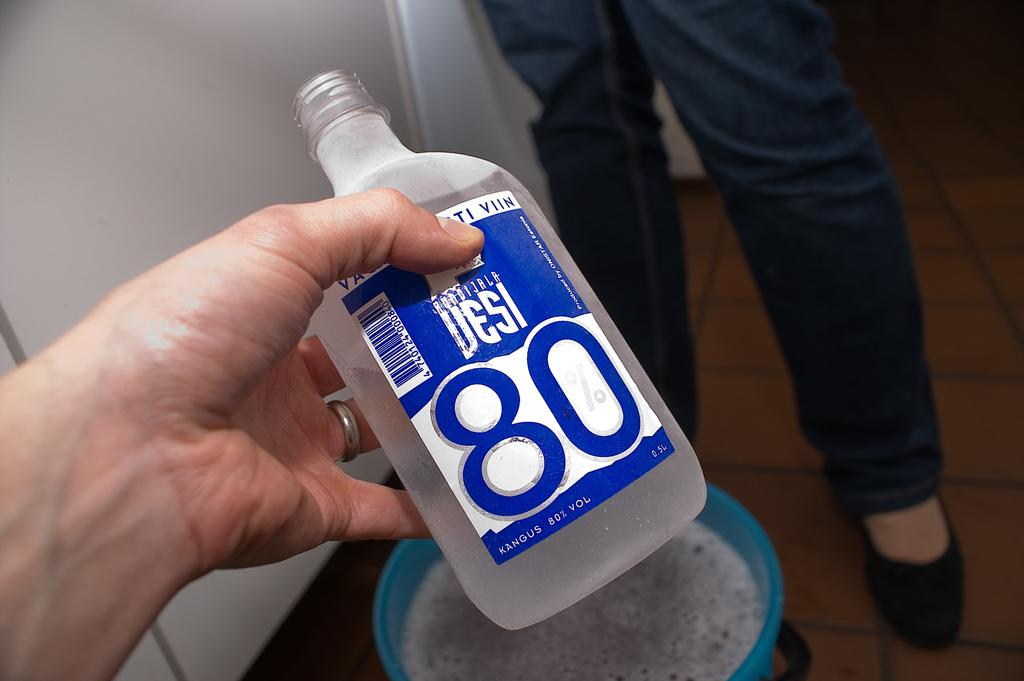<image>
Describe the image concisely. A clear bottle with a blue label of Desi 80% alcohol 